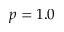Convert formula to latex. <formula><loc_0><loc_0><loc_500><loc_500>p = 1 . 0</formula> 